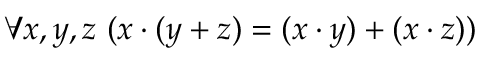<formula> <loc_0><loc_0><loc_500><loc_500>\forall x , y , z \ ( x \cdot ( y + z ) = ( x \cdot y ) + ( x \cdot z ) )</formula> 